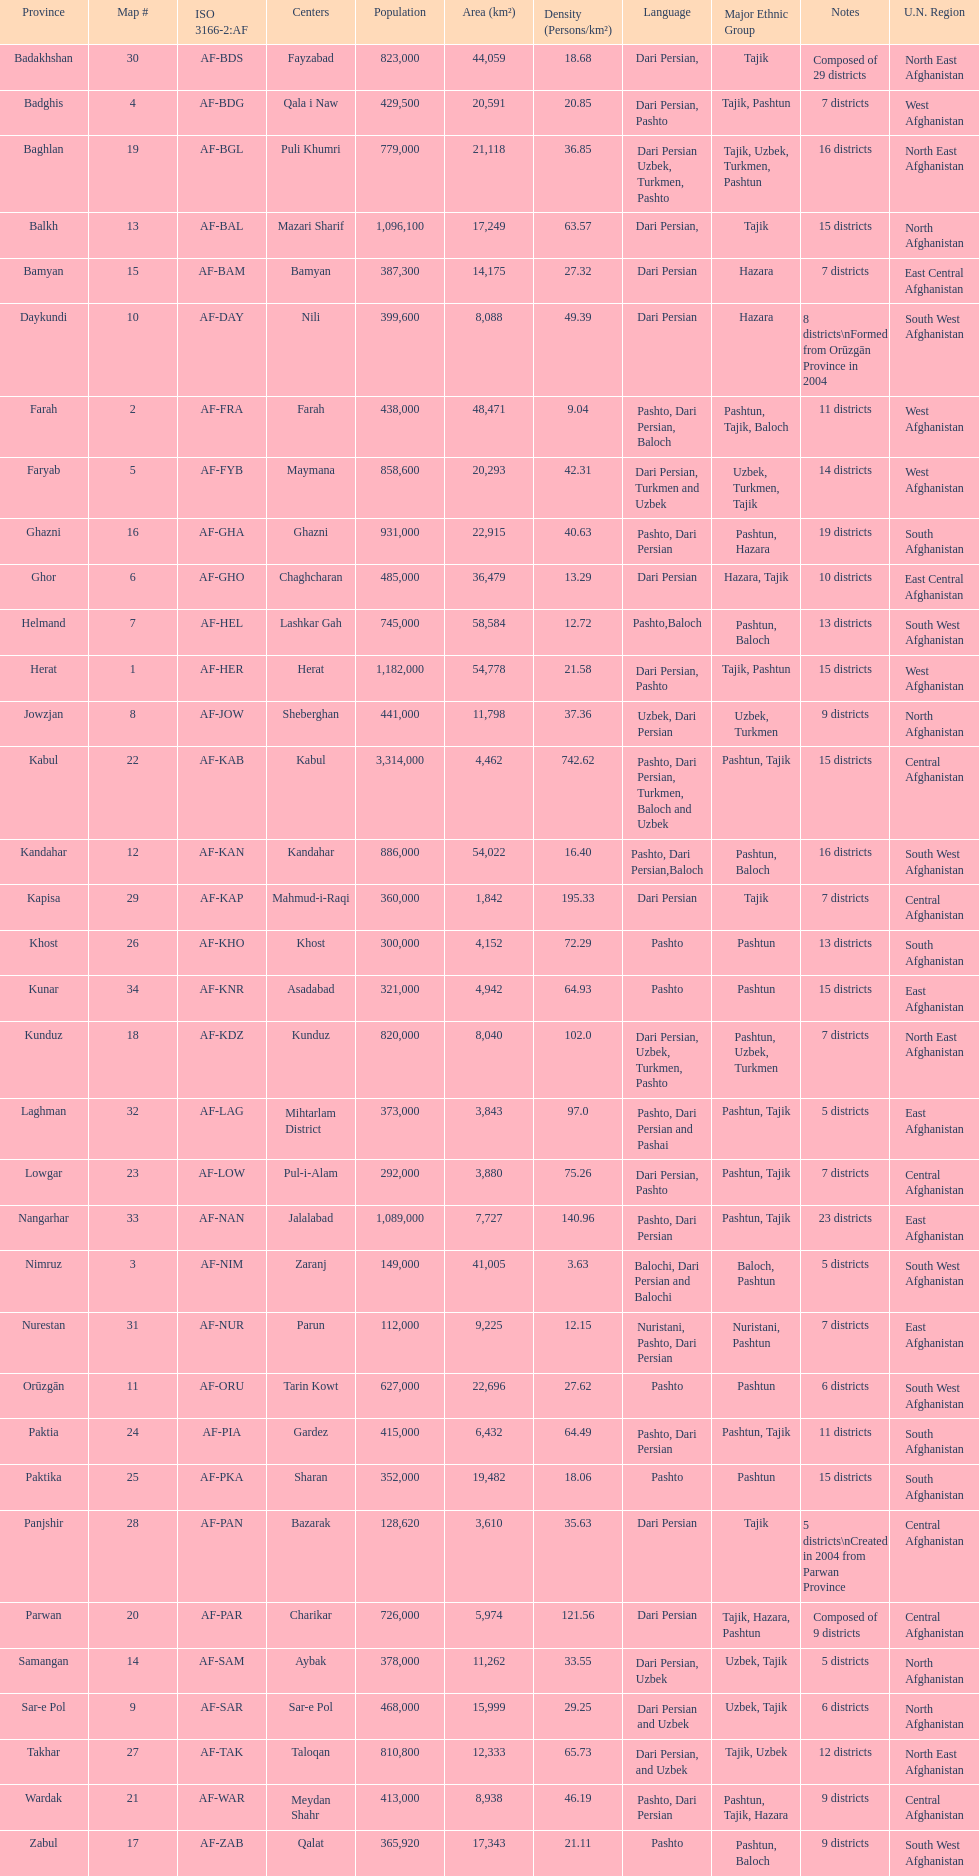Which province has the most districts? Badakhshan. Would you mind parsing the complete table? {'header': ['Province', 'Map #', 'ISO 3166-2:AF', 'Centers', 'Population', 'Area (km²)', 'Density (Persons/km²)', 'Language', 'Major Ethnic Group', 'Notes', 'U.N. Region'], 'rows': [['Badakhshan', '30', 'AF-BDS', 'Fayzabad', '823,000', '44,059', '18.68', 'Dari Persian,', 'Tajik', 'Composed of 29 districts', 'North East Afghanistan'], ['Badghis', '4', 'AF-BDG', 'Qala i Naw', '429,500', '20,591', '20.85', 'Dari Persian, Pashto', 'Tajik, Pashtun', '7 districts', 'West Afghanistan'], ['Baghlan', '19', 'AF-BGL', 'Puli Khumri', '779,000', '21,118', '36.85', 'Dari Persian Uzbek, Turkmen, Pashto', 'Tajik, Uzbek, Turkmen, Pashtun', '16 districts', 'North East Afghanistan'], ['Balkh', '13', 'AF-BAL', 'Mazari Sharif', '1,096,100', '17,249', '63.57', 'Dari Persian,', 'Tajik', '15 districts', 'North Afghanistan'], ['Bamyan', '15', 'AF-BAM', 'Bamyan', '387,300', '14,175', '27.32', 'Dari Persian', 'Hazara', '7 districts', 'East Central Afghanistan'], ['Daykundi', '10', 'AF-DAY', 'Nili', '399,600', '8,088', '49.39', 'Dari Persian', 'Hazara', '8 districts\\nFormed from Orūzgān Province in 2004', 'South West Afghanistan'], ['Farah', '2', 'AF-FRA', 'Farah', '438,000', '48,471', '9.04', 'Pashto, Dari Persian, Baloch', 'Pashtun, Tajik, Baloch', '11 districts', 'West Afghanistan'], ['Faryab', '5', 'AF-FYB', 'Maymana', '858,600', '20,293', '42.31', 'Dari Persian, Turkmen and Uzbek', 'Uzbek, Turkmen, Tajik', '14 districts', 'West Afghanistan'], ['Ghazni', '16', 'AF-GHA', 'Ghazni', '931,000', '22,915', '40.63', 'Pashto, Dari Persian', 'Pashtun, Hazara', '19 districts', 'South Afghanistan'], ['Ghor', '6', 'AF-GHO', 'Chaghcharan', '485,000', '36,479', '13.29', 'Dari Persian', 'Hazara, Tajik', '10 districts', 'East Central Afghanistan'], ['Helmand', '7', 'AF-HEL', 'Lashkar Gah', '745,000', '58,584', '12.72', 'Pashto,Baloch', 'Pashtun, Baloch', '13 districts', 'South West Afghanistan'], ['Herat', '1', 'AF-HER', 'Herat', '1,182,000', '54,778', '21.58', 'Dari Persian, Pashto', 'Tajik, Pashtun', '15 districts', 'West Afghanistan'], ['Jowzjan', '8', 'AF-JOW', 'Sheberghan', '441,000', '11,798', '37.36', 'Uzbek, Dari Persian', 'Uzbek, Turkmen', '9 districts', 'North Afghanistan'], ['Kabul', '22', 'AF-KAB', 'Kabul', '3,314,000', '4,462', '742.62', 'Pashto, Dari Persian, Turkmen, Baloch and Uzbek', 'Pashtun, Tajik', '15 districts', 'Central Afghanistan'], ['Kandahar', '12', 'AF-KAN', 'Kandahar', '886,000', '54,022', '16.40', 'Pashto, Dari Persian,Baloch', 'Pashtun, Baloch', '16 districts', 'South West Afghanistan'], ['Kapisa', '29', 'AF-KAP', 'Mahmud-i-Raqi', '360,000', '1,842', '195.33', 'Dari Persian', 'Tajik', '7 districts', 'Central Afghanistan'], ['Khost', '26', 'AF-KHO', 'Khost', '300,000', '4,152', '72.29', 'Pashto', 'Pashtun', '13 districts', 'South Afghanistan'], ['Kunar', '34', 'AF-KNR', 'Asadabad', '321,000', '4,942', '64.93', 'Pashto', 'Pashtun', '15 districts', 'East Afghanistan'], ['Kunduz', '18', 'AF-KDZ', 'Kunduz', '820,000', '8,040', '102.0', 'Dari Persian, Uzbek, Turkmen, Pashto', 'Pashtun, Uzbek, Turkmen', '7 districts', 'North East Afghanistan'], ['Laghman', '32', 'AF-LAG', 'Mihtarlam District', '373,000', '3,843', '97.0', 'Pashto, Dari Persian and Pashai', 'Pashtun, Tajik', '5 districts', 'East Afghanistan'], ['Lowgar', '23', 'AF-LOW', 'Pul-i-Alam', '292,000', '3,880', '75.26', 'Dari Persian, Pashto', 'Pashtun, Tajik', '7 districts', 'Central Afghanistan'], ['Nangarhar', '33', 'AF-NAN', 'Jalalabad', '1,089,000', '7,727', '140.96', 'Pashto, Dari Persian', 'Pashtun, Tajik', '23 districts', 'East Afghanistan'], ['Nimruz', '3', 'AF-NIM', 'Zaranj', '149,000', '41,005', '3.63', 'Balochi, Dari Persian and Balochi', 'Baloch, Pashtun', '5 districts', 'South West Afghanistan'], ['Nurestan', '31', 'AF-NUR', 'Parun', '112,000', '9,225', '12.15', 'Nuristani, Pashto, Dari Persian', 'Nuristani, Pashtun', '7 districts', 'East Afghanistan'], ['Orūzgān', '11', 'AF-ORU', 'Tarin Kowt', '627,000', '22,696', '27.62', 'Pashto', 'Pashtun', '6 districts', 'South West Afghanistan'], ['Paktia', '24', 'AF-PIA', 'Gardez', '415,000', '6,432', '64.49', 'Pashto, Dari Persian', 'Pashtun, Tajik', '11 districts', 'South Afghanistan'], ['Paktika', '25', 'AF-PKA', 'Sharan', '352,000', '19,482', '18.06', 'Pashto', 'Pashtun', '15 districts', 'South Afghanistan'], ['Panjshir', '28', 'AF-PAN', 'Bazarak', '128,620', '3,610', '35.63', 'Dari Persian', 'Tajik', '5 districts\\nCreated in 2004 from Parwan Province', 'Central Afghanistan'], ['Parwan', '20', 'AF-PAR', 'Charikar', '726,000', '5,974', '121.56', 'Dari Persian', 'Tajik, Hazara, Pashtun', 'Composed of 9 districts', 'Central Afghanistan'], ['Samangan', '14', 'AF-SAM', 'Aybak', '378,000', '11,262', '33.55', 'Dari Persian, Uzbek', 'Uzbek, Tajik', '5 districts', 'North Afghanistan'], ['Sar-e Pol', '9', 'AF-SAR', 'Sar-e Pol', '468,000', '15,999', '29.25', 'Dari Persian and Uzbek', 'Uzbek, Tajik', '6 districts', 'North Afghanistan'], ['Takhar', '27', 'AF-TAK', 'Taloqan', '810,800', '12,333', '65.73', 'Dari Persian, and Uzbek', 'Tajik, Uzbek', '12 districts', 'North East Afghanistan'], ['Wardak', '21', 'AF-WAR', 'Meydan Shahr', '413,000', '8,938', '46.19', 'Pashto, Dari Persian', 'Pashtun, Tajik, Hazara', '9 districts', 'Central Afghanistan'], ['Zabul', '17', 'AF-ZAB', 'Qalat', '365,920', '17,343', '21.11', 'Pashto', 'Pashtun, Baloch', '9 districts', 'South West Afghanistan']]} 